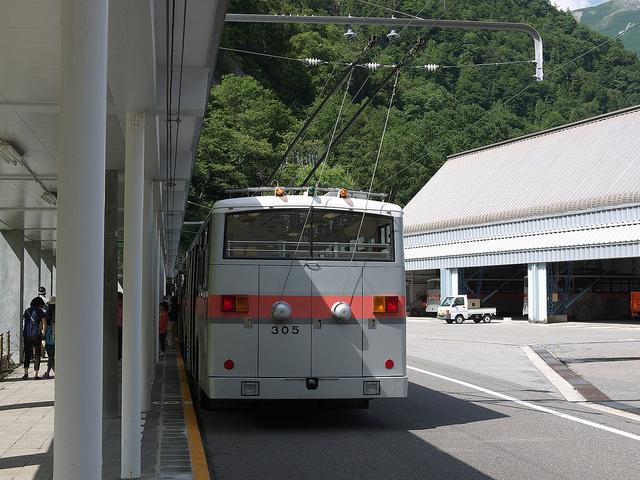Is there precipitation on the ground?
Give a very brief answer. No. How many buses are in the picture?
Short answer required. 1. Has the train stopped?
Keep it brief. Yes. What is he standing on?
Give a very brief answer. Sidewalk. Is the train attached to wires?
Answer briefly. Yes. Is the train on a track?
Keep it brief. No. Is the train leaving?
Quick response, please. No. Are there lights on at the station?
Be succinct. No. 